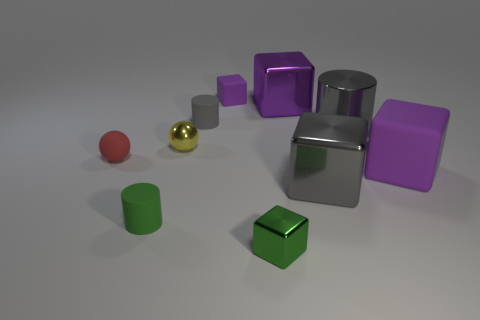How many purple blocks must be subtracted to get 1 purple blocks? 2 Subtract all tiny metal cubes. How many cubes are left? 4 Subtract all red spheres. How many spheres are left? 1 Subtract 3 blocks. How many blocks are left? 2 Subtract all yellow balls. How many purple cubes are left? 3 Add 8 big cyan shiny spheres. How many big cyan shiny spheres exist? 8 Subtract 0 brown cylinders. How many objects are left? 10 Subtract all cylinders. How many objects are left? 7 Subtract all yellow cylinders. Subtract all purple cubes. How many cylinders are left? 3 Subtract all metal blocks. Subtract all small metallic cubes. How many objects are left? 6 